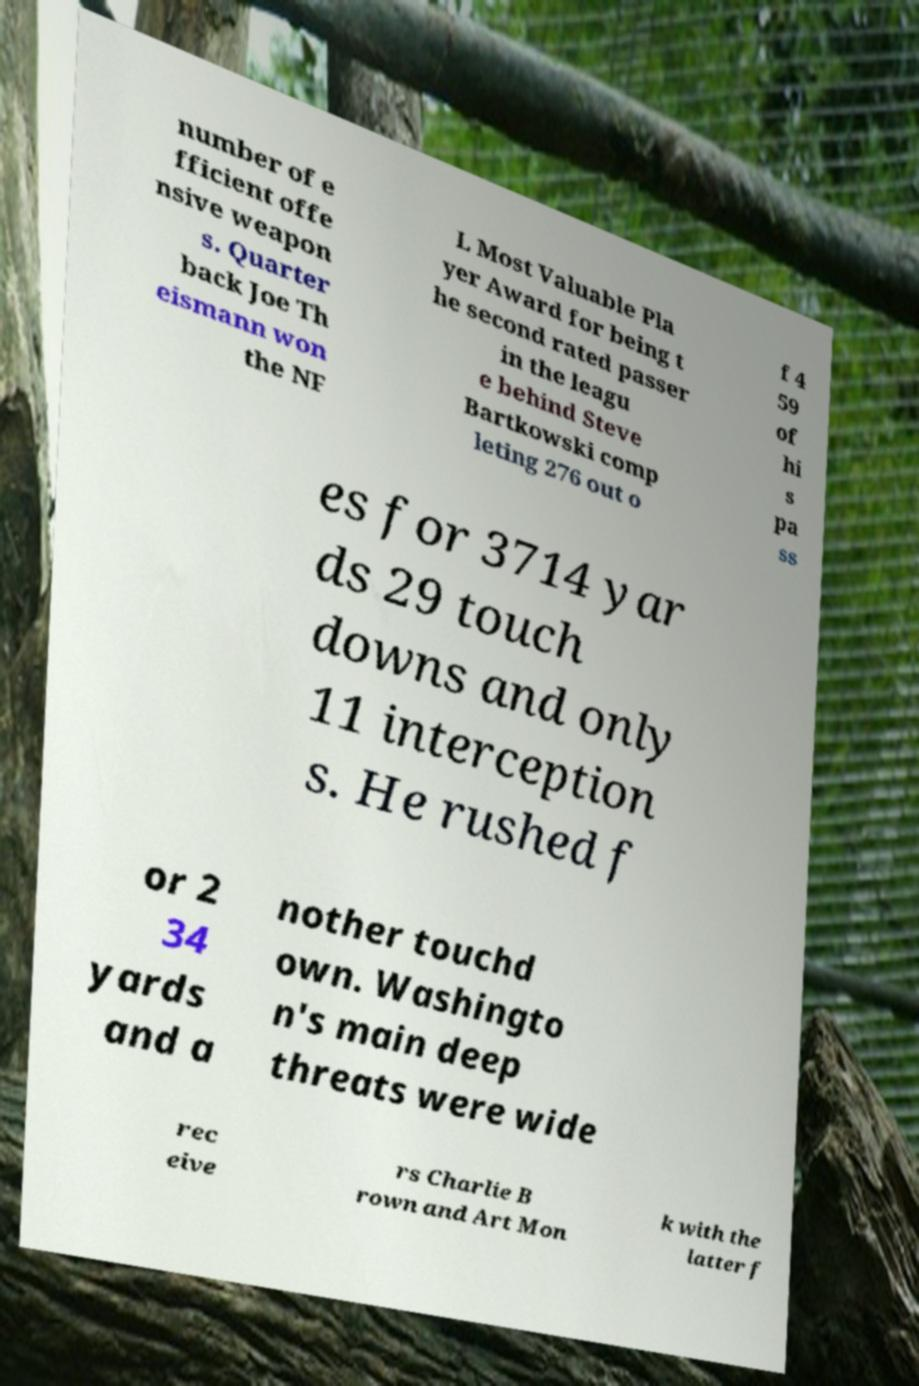What messages or text are displayed in this image? I need them in a readable, typed format. number of e fficient offe nsive weapon s. Quarter back Joe Th eismann won the NF L Most Valuable Pla yer Award for being t he second rated passer in the leagu e behind Steve Bartkowski comp leting 276 out o f 4 59 of hi s pa ss es for 3714 yar ds 29 touch downs and only 11 interception s. He rushed f or 2 34 yards and a nother touchd own. Washingto n's main deep threats were wide rec eive rs Charlie B rown and Art Mon k with the latter f 